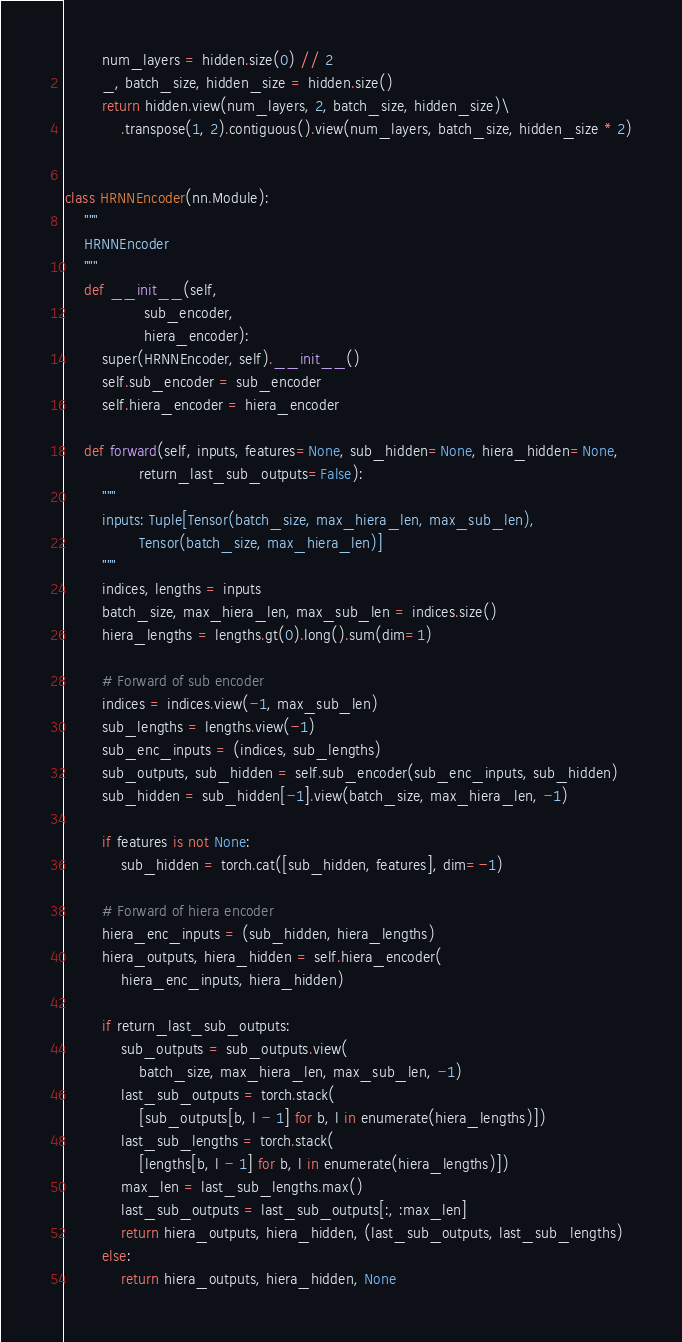<code> <loc_0><loc_0><loc_500><loc_500><_Python_>        num_layers = hidden.size(0) // 2
        _, batch_size, hidden_size = hidden.size()
        return hidden.view(num_layers, 2, batch_size, hidden_size)\
            .transpose(1, 2).contiguous().view(num_layers, batch_size, hidden_size * 2)


class HRNNEncoder(nn.Module):
    """
    HRNNEncoder
    """
    def __init__(self,
                 sub_encoder,
                 hiera_encoder):
        super(HRNNEncoder, self).__init__()
        self.sub_encoder = sub_encoder
        self.hiera_encoder = hiera_encoder

    def forward(self, inputs, features=None, sub_hidden=None, hiera_hidden=None,
                return_last_sub_outputs=False):
        """
        inputs: Tuple[Tensor(batch_size, max_hiera_len, max_sub_len), 
                Tensor(batch_size, max_hiera_len)]
        """
        indices, lengths = inputs
        batch_size, max_hiera_len, max_sub_len = indices.size()
        hiera_lengths = lengths.gt(0).long().sum(dim=1)

        # Forward of sub encoder
        indices = indices.view(-1, max_sub_len)
        sub_lengths = lengths.view(-1)
        sub_enc_inputs = (indices, sub_lengths)
        sub_outputs, sub_hidden = self.sub_encoder(sub_enc_inputs, sub_hidden)
        sub_hidden = sub_hidden[-1].view(batch_size, max_hiera_len, -1)

        if features is not None:
            sub_hidden = torch.cat([sub_hidden, features], dim=-1)

        # Forward of hiera encoder
        hiera_enc_inputs = (sub_hidden, hiera_lengths)
        hiera_outputs, hiera_hidden = self.hiera_encoder(
            hiera_enc_inputs, hiera_hidden)

        if return_last_sub_outputs:
            sub_outputs = sub_outputs.view(
                batch_size, max_hiera_len, max_sub_len, -1)
            last_sub_outputs = torch.stack(
                [sub_outputs[b, l - 1] for b, l in enumerate(hiera_lengths)])
            last_sub_lengths = torch.stack(
                [lengths[b, l - 1] for b, l in enumerate(hiera_lengths)])
            max_len = last_sub_lengths.max()
            last_sub_outputs = last_sub_outputs[:, :max_len]
            return hiera_outputs, hiera_hidden, (last_sub_outputs, last_sub_lengths)
        else:
            return hiera_outputs, hiera_hidden, None
</code> 